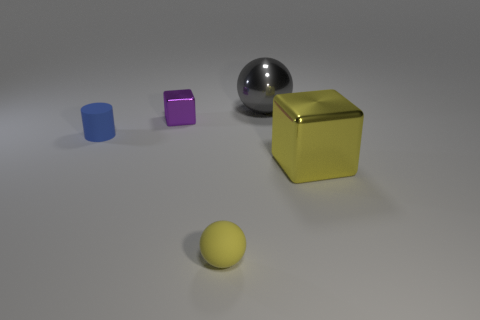Add 4 large blue cylinders. How many objects exist? 9 Subtract all balls. How many objects are left? 3 Subtract all tiny green balls. Subtract all blue cylinders. How many objects are left? 4 Add 2 small blue things. How many small blue things are left? 3 Add 5 large yellow shiny spheres. How many large yellow shiny spheres exist? 5 Subtract 0 cyan spheres. How many objects are left? 5 